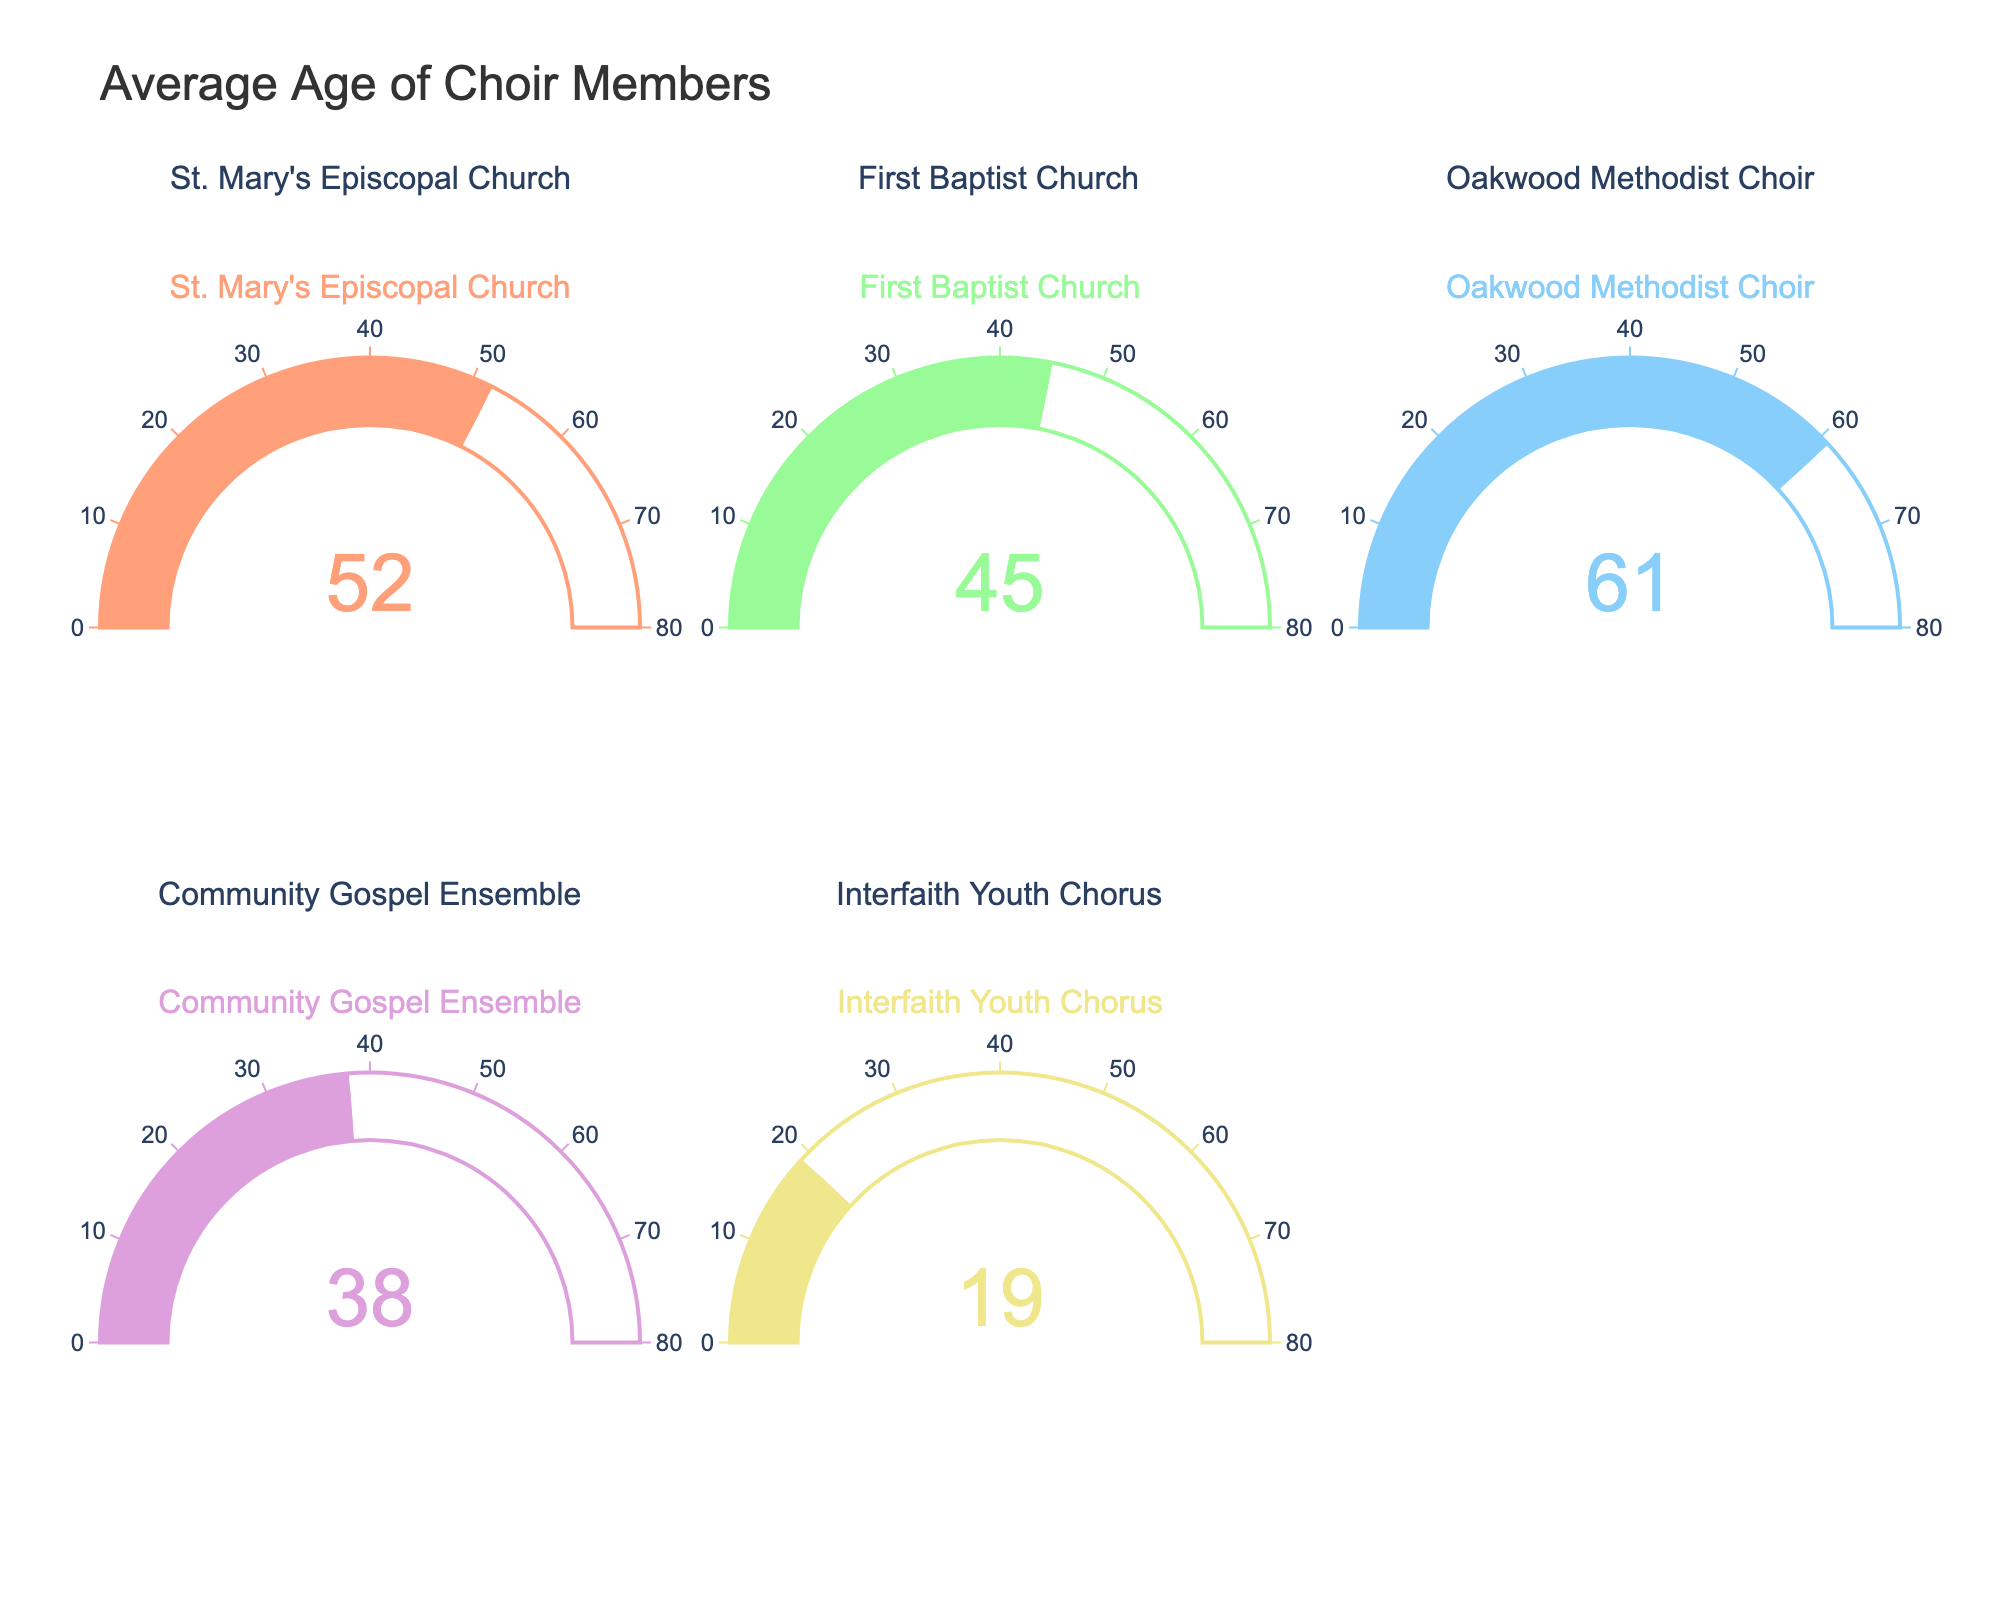what is the average age of choir members in Oakwood Methodist Choir? The gauge chart indicates that the average age of Oakwood Methodist Choir members is displayed as 61.
Answer: 61 What is the title of the figure? The figure has a main title which is written at the top of the plot, it reads "Average Age of Choir Members".
Answer: Average Age of Choir Members Which choir has the youngest average age? By examining each gauge, we can see that the Interfaith Youth Chorus has the youngest average age, which is 19.
Answer: Interfaith Youth Chorus What is the difference between the average ages of First Baptist Church and Community Gospel Ensemble choir members? The gauge chart shows that the average age of First Baptist Church is 45, and Community Gospel Ensemble is 38. Therefore, the difference is 45 - 38 = 7 years.
Answer: 7 How many choirs have an average age above 50? By checking each gauge, we find that St. Mary's Episcopal Church (52), Oakwood Methodist Choir (61) have average ages above 50. That makes a total of 2 choirs.
Answer: 2 What is the combined average age of choir members in St. Mary's Episcopal Church and Interfaith Youth Chorus? From the gauges, the average ages are 52 and 19 respectively. Adding these two values gives 52 + 19 = 71.
Answer: 71 Which choir has the highest average age? The gauge chart shows that Oakwood Methodist Choir has the highest average age of 61.
Answer: Oakwood Methodist Choir Rank the choirs by their average age from youngest to oldest. By examining the gauge values, the choirs ranked from youngest to oldest are Interfaith Youth Chorus (19), Community Gospel Ensemble (38), First Baptist Church (45), St. Mary's Episcopal Church (52), Oakwood Methodist Choir (61).
Answer: Interfaith Youth Chorus, Community Gospel Ensemble, First Baptist Church, St. Mary's Episcopal Church, Oakwood Methodist Choir What is the median average age among all choirs? Arranging the average ages in order: 19, 38, 45, 52, 61. The middle value, and thus the median, is 45.
Answer: 45 